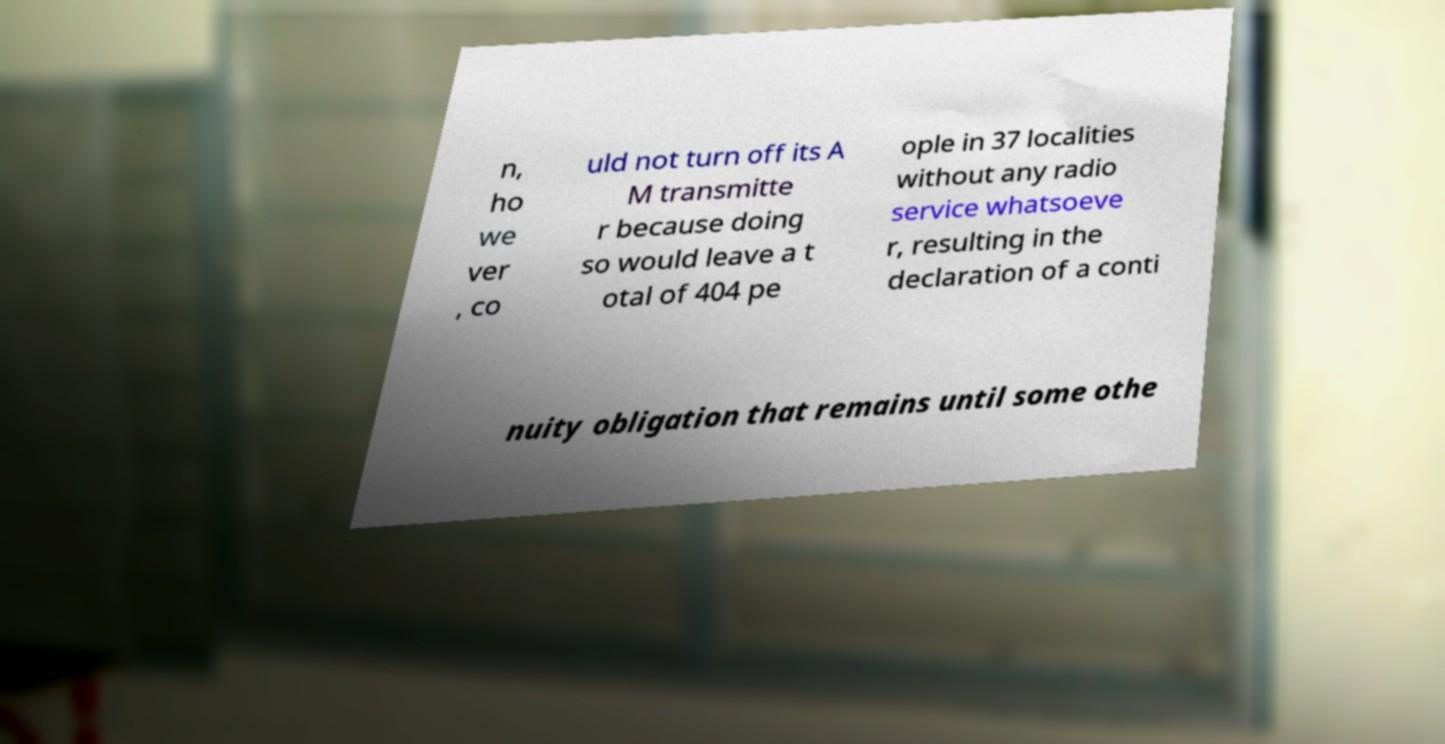Could you extract and type out the text from this image? n, ho we ver , co uld not turn off its A M transmitte r because doing so would leave a t otal of 404 pe ople in 37 localities without any radio service whatsoeve r, resulting in the declaration of a conti nuity obligation that remains until some othe 